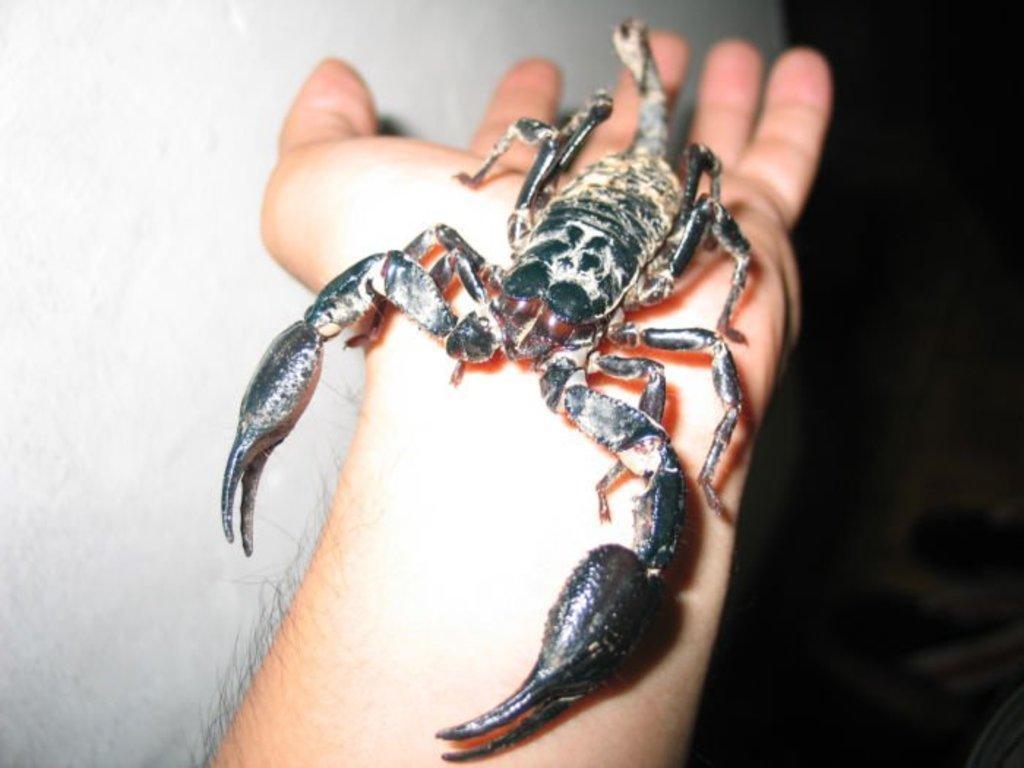Describe this image in one or two sentences. In the picture I can a Scorpion on a person's hand. The right side of the image is dark and on the left side of the image in the background we can see a white color wall. 